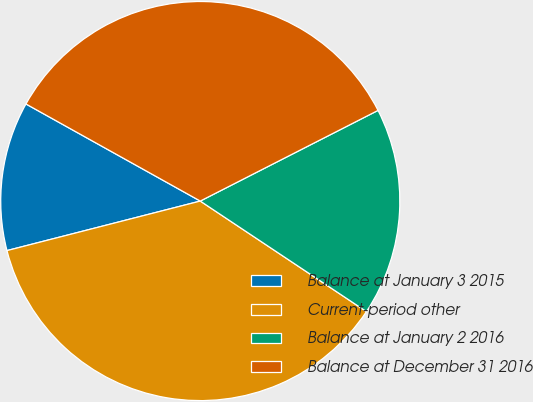<chart> <loc_0><loc_0><loc_500><loc_500><pie_chart><fcel>Balance at January 3 2015<fcel>Current-period other<fcel>Balance at January 2 2016<fcel>Balance at December 31 2016<nl><fcel>12.08%<fcel>36.67%<fcel>16.85%<fcel>34.41%<nl></chart> 